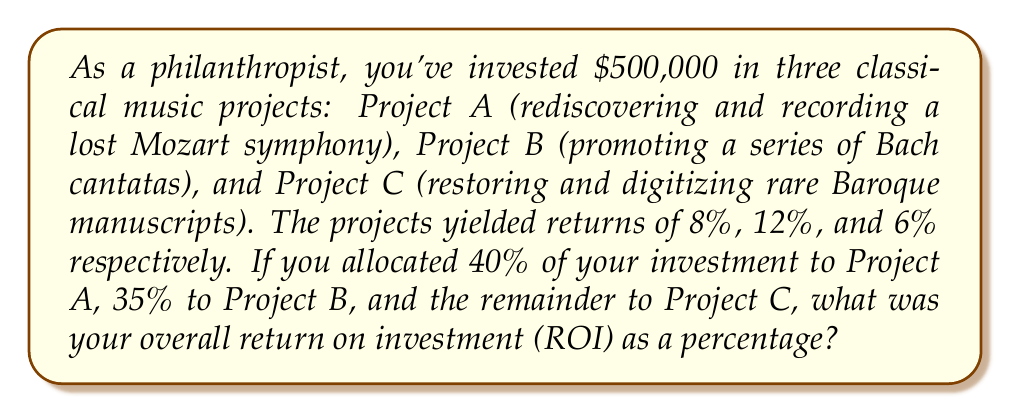Show me your answer to this math problem. Let's approach this step-by-step:

1) First, let's calculate the amount invested in each project:
   Project A: $500,000 * 40% = $200,000
   Project B: $500,000 * 35% = $175,000
   Project C: $500,000 * 25% = $125,000 (remainder)

2) Now, let's calculate the return for each project:
   Project A: $200,000 * 8%  = $16,000
   Project B: $175,000 * 12% = $21,000
   Project C: $125,000 * 6%  = $7,500

3) Total return:
   $16,000 + $21,000 + $7,500 = $44,500

4) To calculate the overall ROI as a percentage, we use the formula:
   $$ROI = \frac{\text{Gain from Investment} - \text{Cost of Investment}}{\text{Cost of Investment}} \times 100\%$$

5) Plugging in our values:
   $$ROI = \frac{44,500 - 500,000}{500,000} \times 100\% = \frac{44,500}{500,000} \times 100\%$$

6) Simplifying:
   $$ROI = 0.089 \times 100\% = 8.9\%$$

Therefore, the overall return on investment is 8.9%.
Answer: 8.9% 